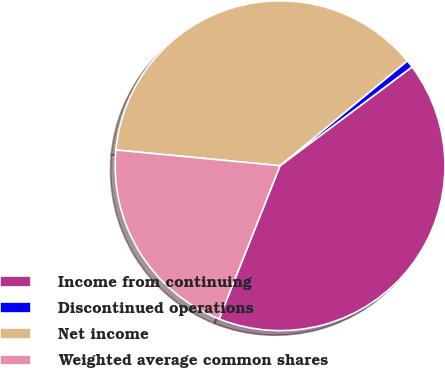Convert chart. <chart><loc_0><loc_0><loc_500><loc_500><pie_chart><fcel>Income from continuing<fcel>Discontinued operations<fcel>Net income<fcel>Weighted average common shares<nl><fcel>41.26%<fcel>0.74%<fcel>37.51%<fcel>20.49%<nl></chart> 